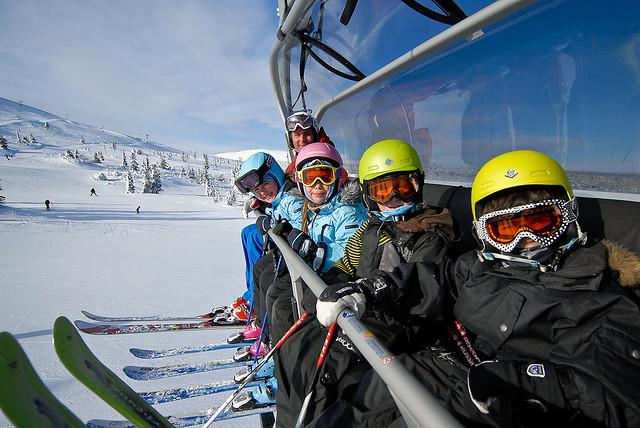What are the people sitting in?
Short answer required. Ski lift. Which helmet is the most traditionally feminine?
Answer briefly. Pink. What are the men riding?
Quick response, please. Ski lift. Is it cold outside?
Be succinct. Yes. 